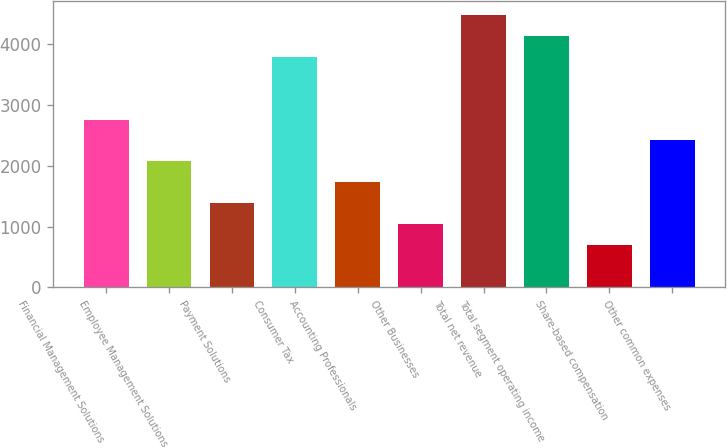<chart> <loc_0><loc_0><loc_500><loc_500><bar_chart><fcel>Financial Management Solutions<fcel>Employee Management Solutions<fcel>Payment Solutions<fcel>Consumer Tax<fcel>Accounting Professionals<fcel>Other Businesses<fcel>Total net revenue<fcel>Total segment operating income<fcel>Share-based compensation<fcel>Other common expenses<nl><fcel>2761<fcel>2073<fcel>1385<fcel>3793<fcel>1729<fcel>1041<fcel>4481<fcel>4137<fcel>697<fcel>2417<nl></chart> 